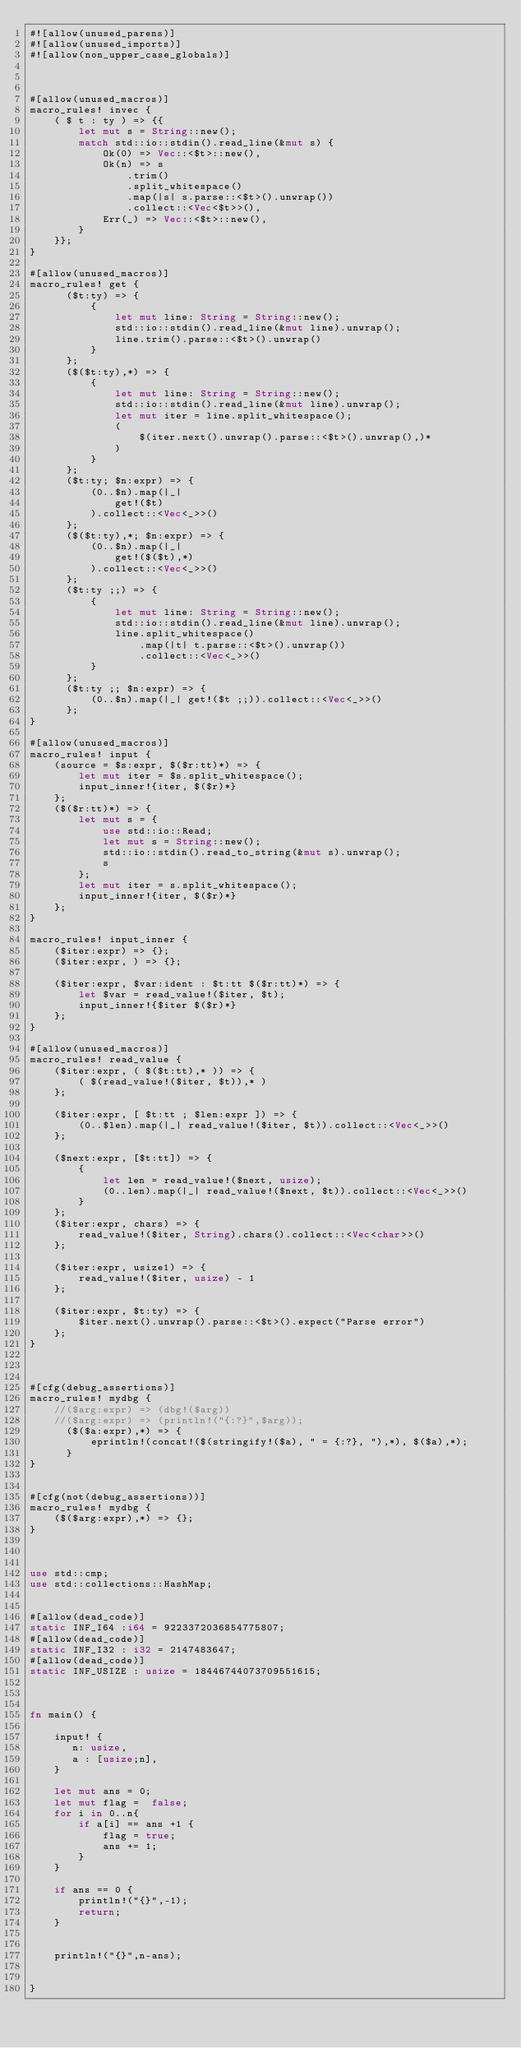<code> <loc_0><loc_0><loc_500><loc_500><_Rust_>#![allow(unused_parens)]
#![allow(unused_imports)]
#![allow(non_upper_case_globals)]



#[allow(unused_macros)]
macro_rules! invec {
    ( $ t : ty ) => {{
        let mut s = String::new();
        match std::io::stdin().read_line(&mut s) {
            Ok(0) => Vec::<$t>::new(),
            Ok(n) => s
                .trim()
                .split_whitespace()
                .map(|s| s.parse::<$t>().unwrap())
                .collect::<Vec<$t>>(),
            Err(_) => Vec::<$t>::new(),
        }
    }};
}

#[allow(unused_macros)]
macro_rules! get {
      ($t:ty) => {
          {
              let mut line: String = String::new();
              std::io::stdin().read_line(&mut line).unwrap();
              line.trim().parse::<$t>().unwrap()
          }
      };
      ($($t:ty),*) => {
          {
              let mut line: String = String::new();
              std::io::stdin().read_line(&mut line).unwrap();
              let mut iter = line.split_whitespace();
              (
                  $(iter.next().unwrap().parse::<$t>().unwrap(),)*
              )
          }
      };
      ($t:ty; $n:expr) => {
          (0..$n).map(|_|
              get!($t)
          ).collect::<Vec<_>>()
      };
      ($($t:ty),*; $n:expr) => {
          (0..$n).map(|_|
              get!($($t),*)
          ).collect::<Vec<_>>()
      };
      ($t:ty ;;) => {
          {
              let mut line: String = String::new();
              std::io::stdin().read_line(&mut line).unwrap();
              line.split_whitespace()
                  .map(|t| t.parse::<$t>().unwrap())
                  .collect::<Vec<_>>()
          }
      };
      ($t:ty ;; $n:expr) => {
          (0..$n).map(|_| get!($t ;;)).collect::<Vec<_>>()
      };
}

#[allow(unused_macros)]
macro_rules! input {
    (source = $s:expr, $($r:tt)*) => {
        let mut iter = $s.split_whitespace();
        input_inner!{iter, $($r)*}
    };
    ($($r:tt)*) => {
        let mut s = {
            use std::io::Read;
            let mut s = String::new();
            std::io::stdin().read_to_string(&mut s).unwrap();
            s
        };
        let mut iter = s.split_whitespace();
        input_inner!{iter, $($r)*}
    };
}

macro_rules! input_inner {
    ($iter:expr) => {};
    ($iter:expr, ) => {};

    ($iter:expr, $var:ident : $t:tt $($r:tt)*) => {
        let $var = read_value!($iter, $t);
        input_inner!{$iter $($r)*}
    };
}

#[allow(unused_macros)]
macro_rules! read_value {
    ($iter:expr, ( $($t:tt),* )) => {
        ( $(read_value!($iter, $t)),* )
    };

    ($iter:expr, [ $t:tt ; $len:expr ]) => {
        (0..$len).map(|_| read_value!($iter, $t)).collect::<Vec<_>>()
    };

    ($next:expr, [$t:tt]) => {
        {
            let len = read_value!($next, usize);
            (0..len).map(|_| read_value!($next, $t)).collect::<Vec<_>>()
        }
    };
    ($iter:expr, chars) => {
        read_value!($iter, String).chars().collect::<Vec<char>>()
    };

    ($iter:expr, usize1) => {
        read_value!($iter, usize) - 1
    };

    ($iter:expr, $t:ty) => {
        $iter.next().unwrap().parse::<$t>().expect("Parse error")
    };
}


 
#[cfg(debug_assertions)]
macro_rules! mydbg {
    //($arg:expr) => (dbg!($arg))
    //($arg:expr) => (println!("{:?}",$arg));
      ($($a:expr),*) => {
          eprintln!(concat!($(stringify!($a), " = {:?}, "),*), $($a),*);
      }
}
 
 
#[cfg(not(debug_assertions))]
macro_rules! mydbg {
    ($($arg:expr),*) => {};
}



use std::cmp;
use std::collections::HashMap;


#[allow(dead_code)]
static INF_I64 :i64 = 9223372036854775807;
#[allow(dead_code)]
static INF_I32 : i32 = 2147483647;
#[allow(dead_code)]
static INF_USIZE : usize = 18446744073709551615;



fn main() {

    input! { 
       n: usize,
       a : [usize;n],
    }

    let mut ans = 0;
    let mut flag =  false;
    for i in 0..n{
        if a[i] == ans +1 {
            flag = true;
            ans += 1;
        }
    }

    if ans == 0 {
        println!("{}",-1);
        return;
    }
    
    
    println!("{}",n-ans);


}
</code> 